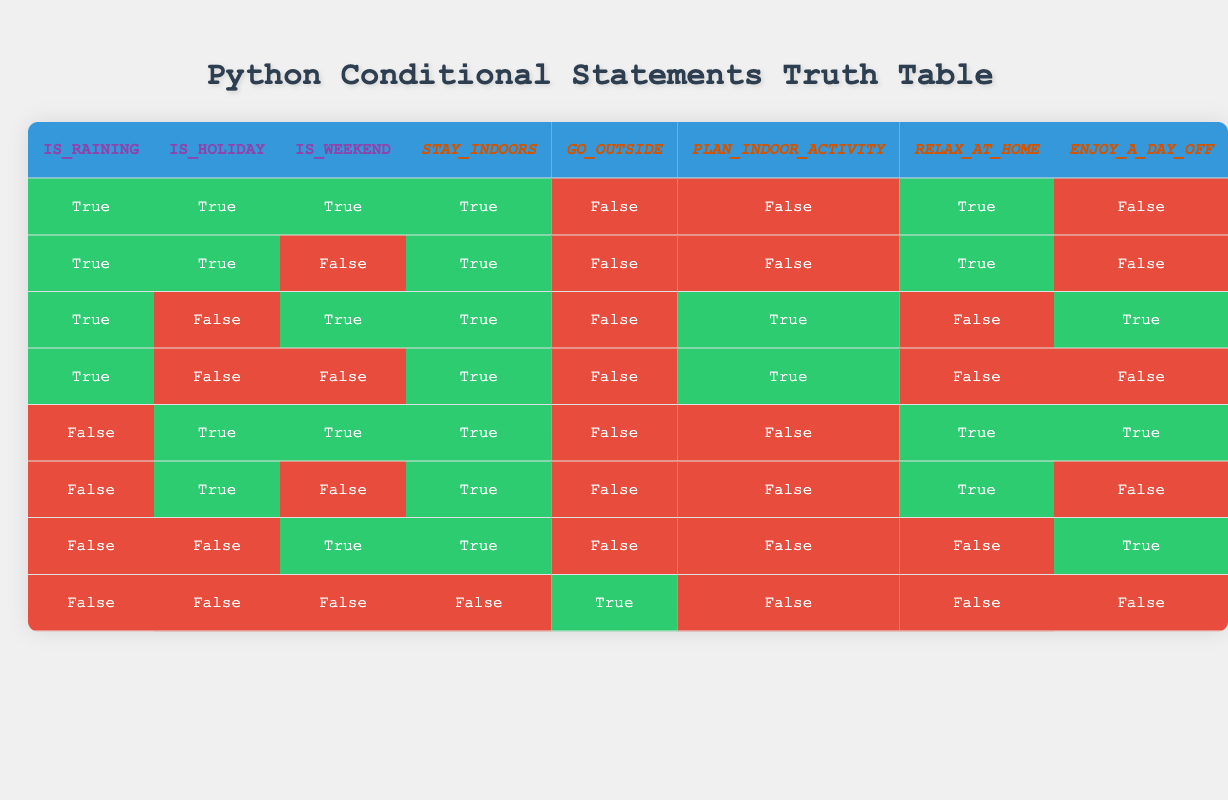Is "Stay Indoors" True when it is a Holiday and it is Raining? Looking at the table, when Is_Raining is True and Is_Holiday is True (the first two rows), Stay Indoors is also True for both scenarios.
Answer: Yes Are there any instances where "Go Outside" is True? In the last row of the table, when Is_Raining is False, Is_Holiday is False, and Is_Weekend is False, we find that Go Outside is True.
Answer: Yes How many scenarios lead to "Plan an Indoor Activity" being True? By examining the table, Plan an Indoor Activity is True in the third and fourth rows, which gives a total of 2 instances out of 8.
Answer: 2 If it is not Raining and it is a Weekend, what is the situation regarding "Relax at Home"? From the last two rows, we see that Relax at Home is True when Is_Holiday is True and Is_Raining is False, which occurs in the fifth row. When Is_Weekend is True, Relax at Home remains False in the sixth row.
Answer: Yes Among all scenarios, what is the total number of times "Enjoy a Day Off" is True? In the truth table, by counting the rows where Enjoy a Day Off is True, we find it is True only in the third and fifth rows, giving a total of 2 instances.
Answer: 2 If it is Raining and it is not a Holiday, what will be the outcome for "Stay Indoors"? Referring to the rows where Is_Raining is True and Is_Holiday is False, both the third and fourth rows show that Stay Indoors is always True when these conditions are met.
Answer: True In how many situations can you "Go Outside" if it is a Holiday? Review the rows where Is_Holiday is True. We can observe that Go Outside is False for both the first and second rows, and also for the fifth and sixth rows. This leads to 0 instances where you can Go Outside if it is a Holiday.
Answer: 0 What is the most common outcome when it is Raining? Analyzing all scenarios where Is_Raining is True, we note that Stay Indoors is consistently True, while Go Outside is always False. Thus, Stay Indoors appears to be the most common outcome in these cases.
Answer: Stay Indoors If it is not a Weekend and it is a Holiday, what activities can be planned? Looking at the rows where Is_Weekend is False and Is_Holiday is True, we find that it applies to the second and sixth rows. In both scenarios, activities like Stay Indoors and Relax at Home are available.
Answer: Stay Indoors and Relax at Home 